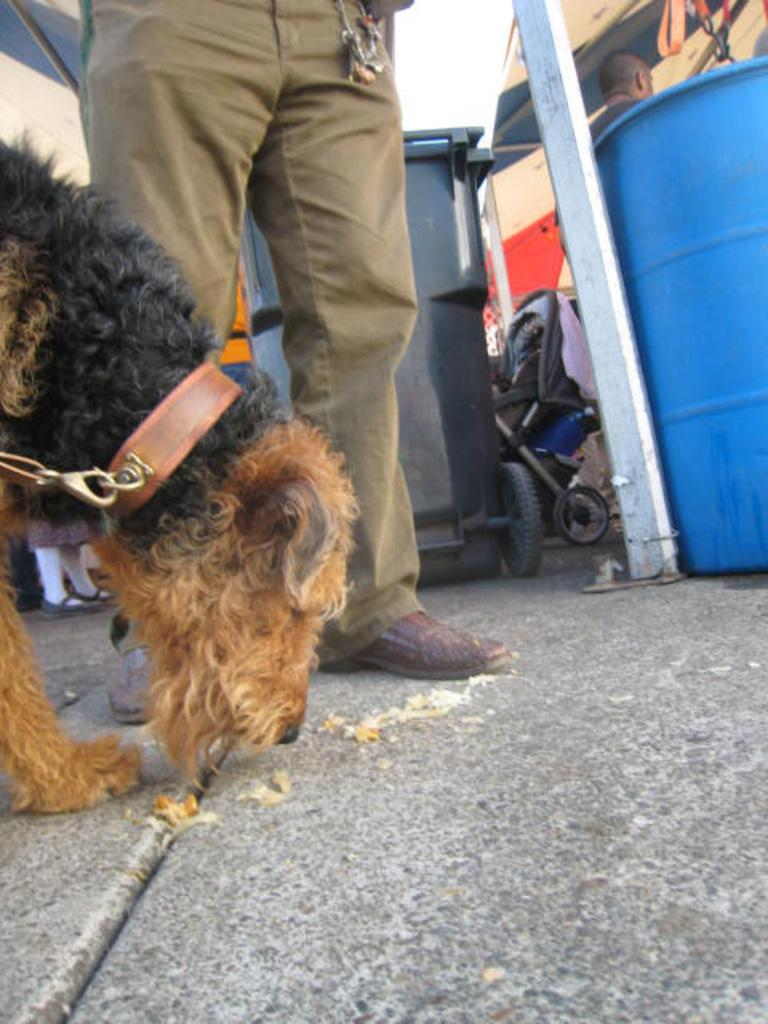What animal can be seen on the ground in the image? There is a dog on the ground in the image. Who else is present in the image besides the dog? There are people in the image. What type of container is visible in the image? There is a bin in the image. What mode of transportation for a baby is present in the image? There is a stroller in the image. What type of items are present in the image? Clothes are present in the image. What other objects can be seen in the image? There are other objects visible in the image. What is the rate of the appliance in the image? There is no appliance present in the image, so it is not possible to determine a rate. 